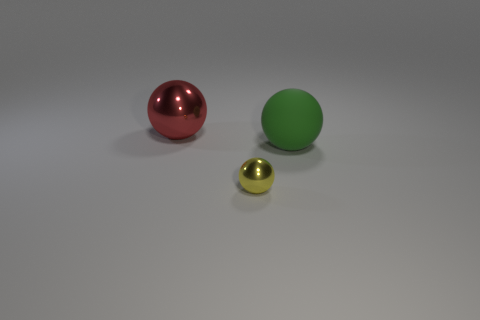Add 1 big green spheres. How many objects exist? 4 Add 2 green matte spheres. How many green matte spheres are left? 3 Add 3 tiny yellow balls. How many tiny yellow balls exist? 4 Subtract 0 cyan blocks. How many objects are left? 3 Subtract all big brown metal cylinders. Subtract all tiny yellow metal objects. How many objects are left? 2 